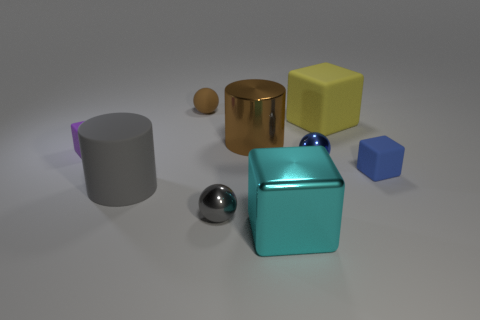What number of spheres are the same color as the metal cylinder?
Make the answer very short. 1. Are there any other things of the same color as the big metal cylinder?
Provide a short and direct response. Yes. What number of things are blocks in front of the brown cylinder or small gray metal balls?
Your response must be concise. 4. There is a gray cylinder left of the blue rubber thing; what material is it?
Provide a succinct answer. Rubber. What is the material of the large brown thing?
Provide a succinct answer. Metal. There is a block that is behind the small matte cube that is left of the rubber block that is in front of the small purple rubber thing; what is it made of?
Provide a short and direct response. Rubber. Are there any other things that have the same material as the yellow block?
Ensure brevity in your answer.  Yes. There is a yellow object; does it have the same size as the brown object that is to the right of the brown matte thing?
Make the answer very short. Yes. What number of things are either big gray objects that are in front of the blue sphere or rubber things to the right of the cyan block?
Give a very brief answer. 3. What is the color of the big rubber object that is right of the big brown object?
Ensure brevity in your answer.  Yellow. 